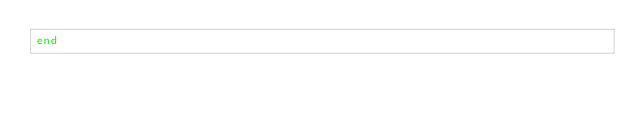Convert code to text. <code><loc_0><loc_0><loc_500><loc_500><_Ruby_>end
</code> 